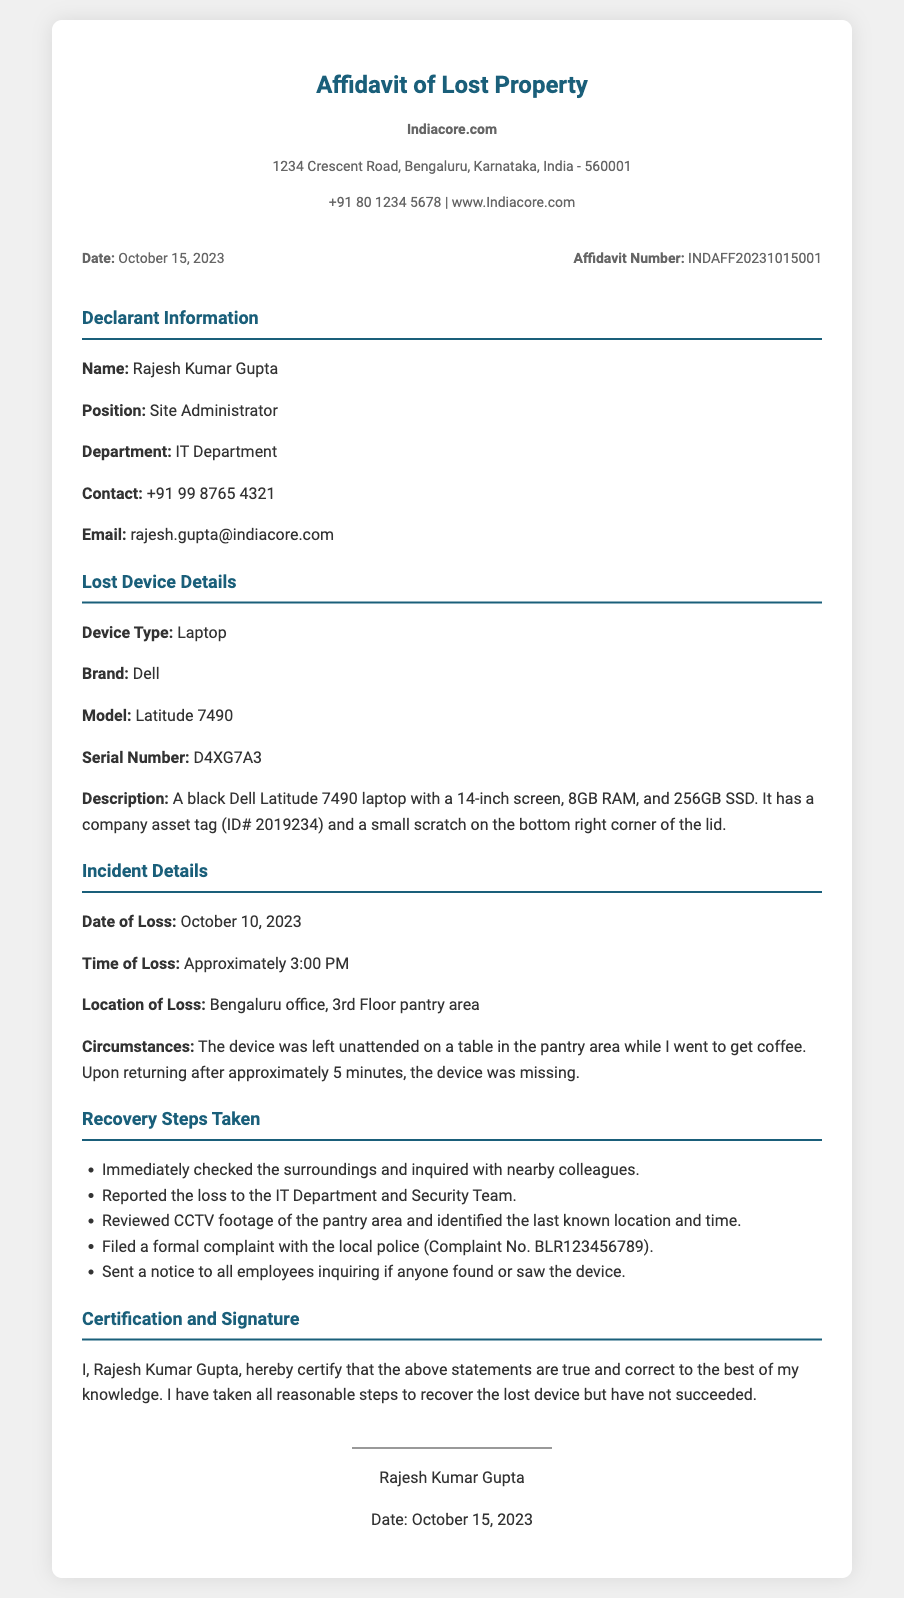What is the date of the affidavit? The date of the affidavit is clearly stated in the document.
Answer: October 15, 2023 Who is the declarant? The declarant's name is listed in the affidavit section.
Answer: Rajesh Kumar Gupta What is the device type? The document specifies the type of device that was lost.
Answer: Laptop What is the serial number of the lost device? The serial number is specifically provided in the lost device details.
Answer: D4XG7A3 What was the time of loss? The approximate time of loss is mentioned in the incident details.
Answer: Approximately 3:00 PM What location was the device lost? The location of the loss is provided in the incident section of the document.
Answer: Bengaluru office, 3rd Floor pantry area What steps were taken to recover the device? The document lists a series of actions taken for recovery.
Answer: Checked surroundings, reported to IT and Security, reviewed CCTV, filed police complaint, sent employee notice What is the model of the lost device? The model of the lost device is specified in the device details section.
Answer: Latitude 7490 What is the company asset tag ID? The asset tag ID is mentioned in the description of the device.
Answer: ID# 2019234 